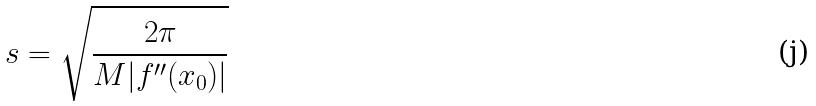Convert formula to latex. <formula><loc_0><loc_0><loc_500><loc_500>s = \sqrt { \frac { 2 \pi } { M | f ^ { \prime \prime } ( x _ { 0 } ) | } }</formula> 